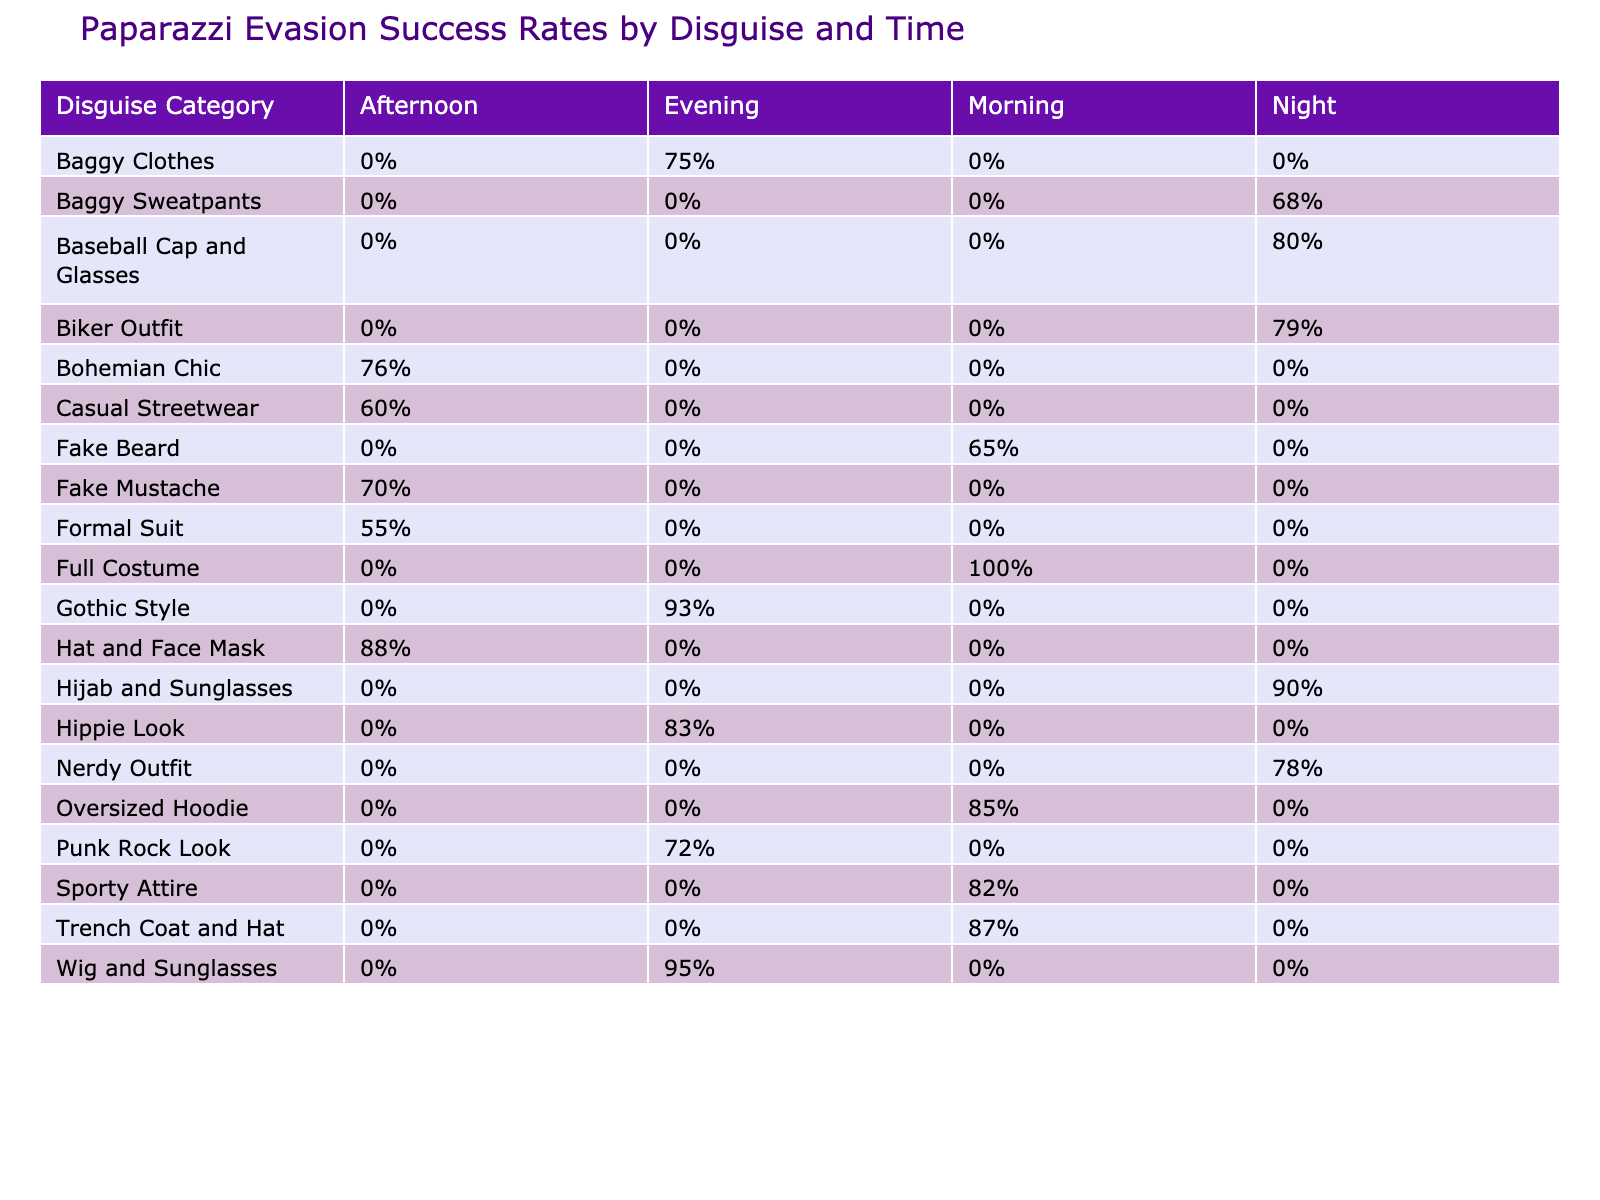What is the evasion success rate for the "Wig and Sunglasses" disguise in the evening? The table shows that the evasion success rate for "Wig and Sunglasses" is 95% in the evening column.
Answer: 95% Which disguise category has the highest evasion success rate during the morning? In the morning column, "Full Costume" has the highest evasion success rate of 100%.
Answer: 100% What is the average evasion success rate for disguises used during the night? The night evasion success rates are 80%, 90%, 68%, and 79%. First, we sum these rates: 80 + 90 + 68 + 79 = 317. Then we divide by the number of attempts, which is 4, to get the average: 317 / 4 = 79.25%.
Answer: 79.25% Did the "Casual Streetwear" disguise result in a higher success rate than the "Formal Suit" during the afternoon? "Casual Streetwear" has an evasion success rate of 60% in the afternoon, while "Formal Suit" has a lower success rate of 55%. Thus, "Casual Streetwear" has a higher success rate than "Formal Suit."
Answer: Yes What is the difference in evasion success rates between the "Hippie Look" and "Gothic Style" in the evening? The "Hippie Look" has a success rate of 83%, and the "Gothic Style" has a success rate of 93%. The difference is 93% - 83% = 10%.
Answer: 10% Which disguise had the most number of attempts in the evening, and what was its success rate? In the evening, "Punk Rock Look" had 14 attempts with a success rate of 72%.
Answer: 72% with 14 attempts Is there any disguise category that had a 100% success rate according to the table? Yes, "Full Costume" achieved a 100% evasion success rate in the morning.
Answer: Yes What is the evasion success rate for "Hijab and Sunglasses" during the night compared to "Baggy Sweatpants"? "Hijab and Sunglasses" has an evasion success rate of 90% in the night column, while "Baggy Sweatpants" has a 68% rate. Therefore, "Hijab and Sunglasses" has a higher success rate.
Answer: Higher for Hijab and Sunglasses (90%) 